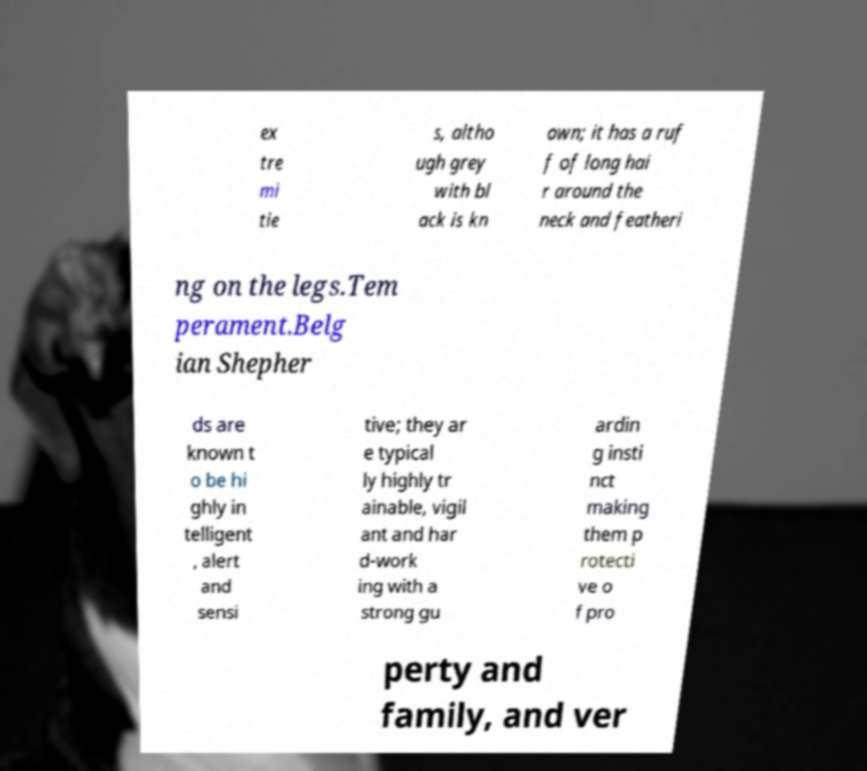For documentation purposes, I need the text within this image transcribed. Could you provide that? ex tre mi tie s, altho ugh grey with bl ack is kn own; it has a ruf f of long hai r around the neck and featheri ng on the legs.Tem perament.Belg ian Shepher ds are known t o be hi ghly in telligent , alert and sensi tive; they ar e typical ly highly tr ainable, vigil ant and har d-work ing with a strong gu ardin g insti nct making them p rotecti ve o f pro perty and family, and ver 